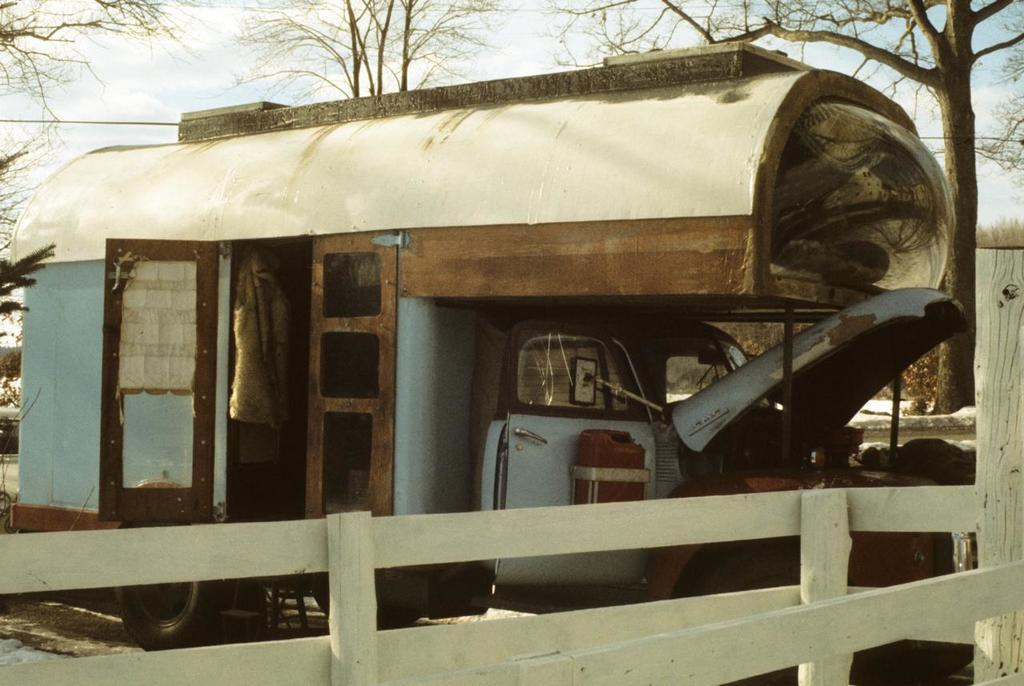What is the main object on the ground in the image? There is a vehicle on the ground in the image. What feature does the vehicle have? The vehicle has doors. What type of natural environment can be seen in the image? There are trees visible in the image. What is visible in the background of the image? The sky is visible in the background of the image. What can be observed in the sky? Clouds are present in the sky. How many accounts does the vehicle have in the image? There are no accounts associated with the vehicle in the image. What type of coastline can be seen in the image? There is no coastline present in the image. 